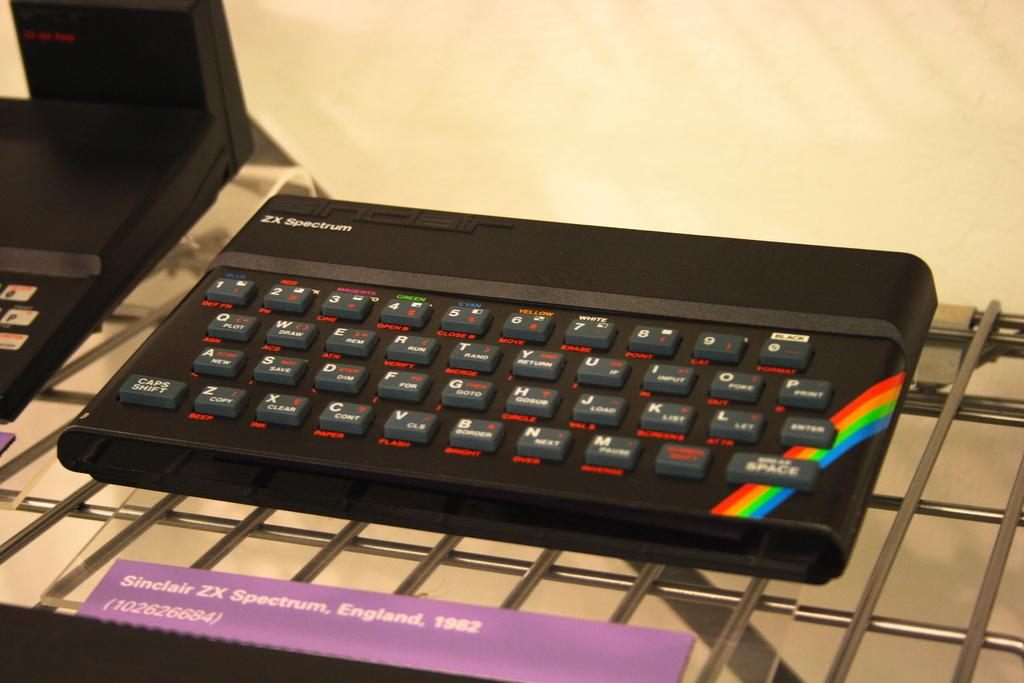<image>
Present a compact description of the photo's key features. ZX Spectrum keyboard with a rainbow on the right side. 